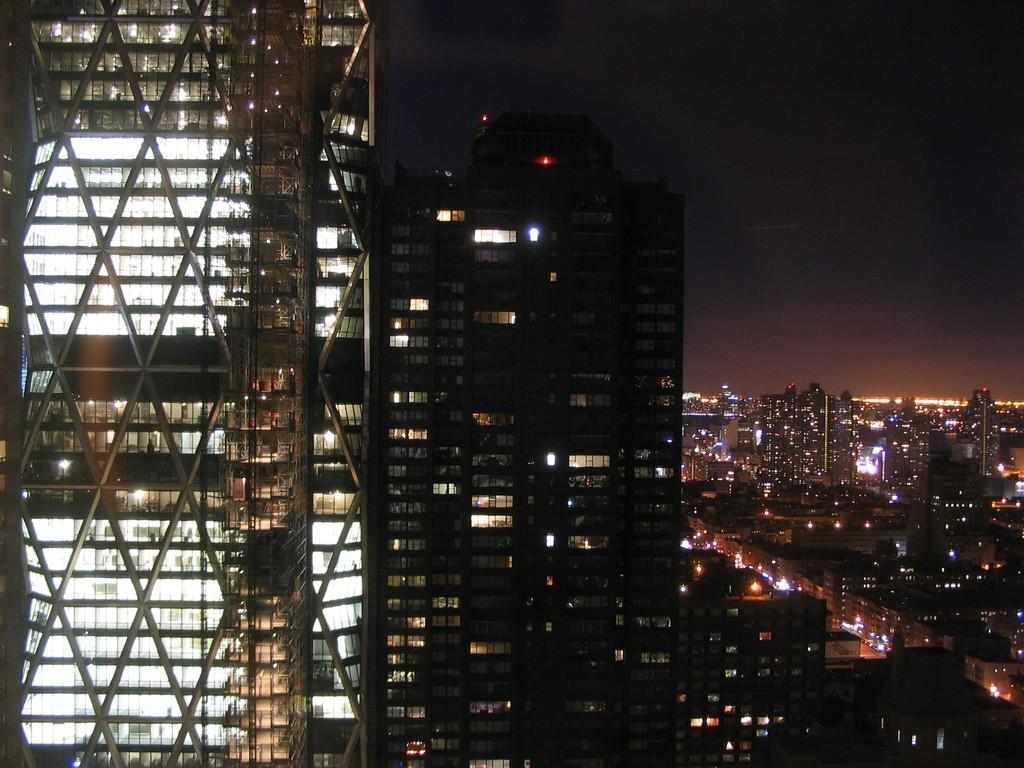What type of structures are present in the image? There is a group of buildings in the image. What can be seen illuminated in the image? There are lights visible in the image. What is visible in the background of the image? The sky is visible in the background of the image. What type of creature can be seen drinking wine in the image? There is no creature or wine present in the image. 